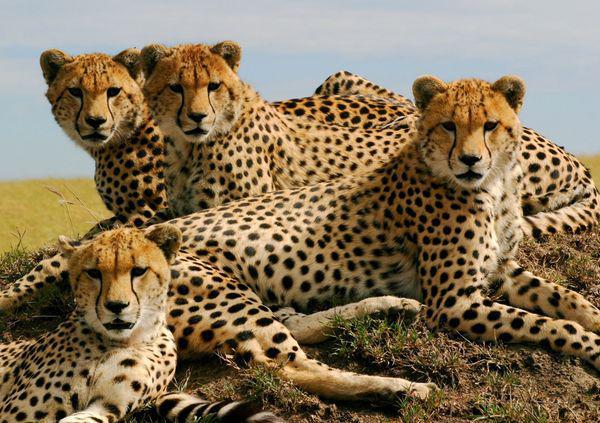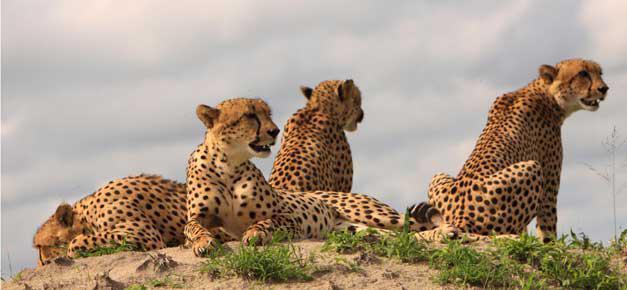The first image is the image on the left, the second image is the image on the right. Examine the images to the left and right. Is the description "At least one cheetah is laying on a mound." accurate? Answer yes or no. Yes. The first image is the image on the left, the second image is the image on the right. For the images displayed, is the sentence "There is at least one cheetah atop a grassy mound" factually correct? Answer yes or no. Yes. 